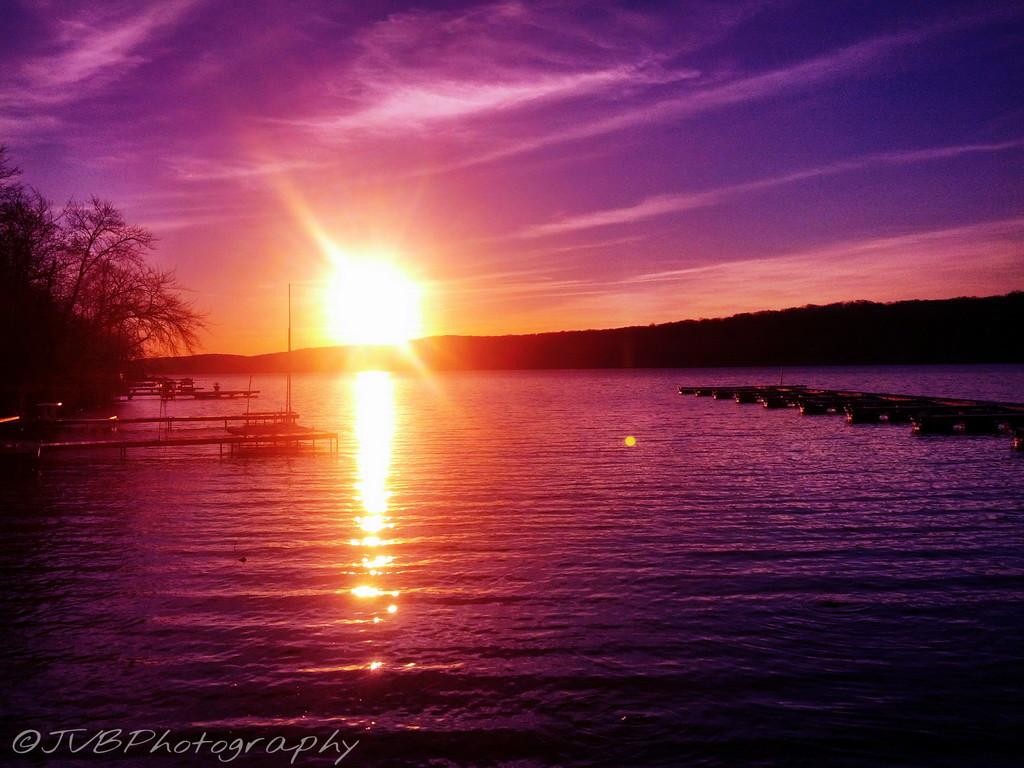What type of natural elements can be seen in the image? There are trees in the image. What celestial body is visible in the image? The sun is visible in the image. What part of the natural environment is visible in the image? The sky is visible in the image. What type of man-made structures can be seen in the image? There are bridges in the image. What objects are floating on the water surface in the image? There are objects on the water surface in the image. How would you describe the appearance of the sky in the image? The sky has a colorful appearance. Can you see an eye in the image? There is no eye present in the image. What type of bucket is floating on the water surface in the image? There is no bucket present in the image; only objects are floating on the water surface. 